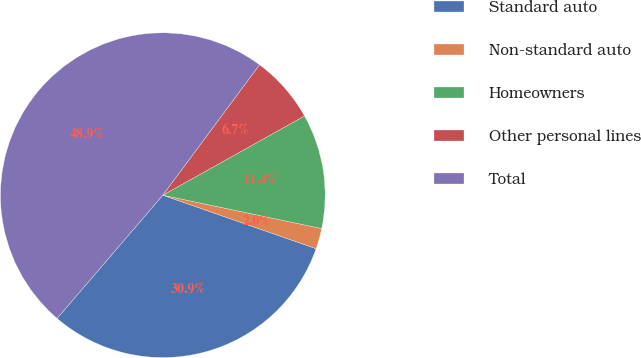<chart> <loc_0><loc_0><loc_500><loc_500><pie_chart><fcel>Standard auto<fcel>Non-standard auto<fcel>Homeowners<fcel>Other personal lines<fcel>Total<nl><fcel>30.94%<fcel>2.05%<fcel>11.41%<fcel>6.73%<fcel>48.87%<nl></chart> 